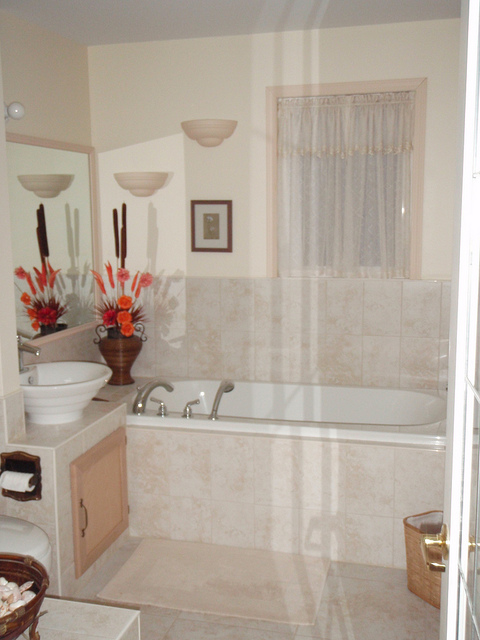<image>What color is the sliding glass door handle? I am not sure what color the sliding glass door handle is. It could be gold, white, chrome, or silver. What color is the sliding glass door handle? I don't know what color the sliding glass door handle is. It is either gold, white, chrome, or silver. 